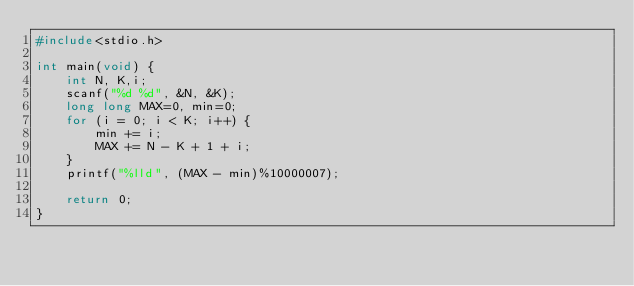<code> <loc_0><loc_0><loc_500><loc_500><_C_>#include<stdio.h>

int main(void) {
	int N, K,i;
	scanf("%d %d", &N, &K);
	long long MAX=0, min=0;
	for (i = 0; i < K; i++) {
		min += i;
		MAX += N - K + 1 + i;
	}
	printf("%lld", (MAX - min)%10000007);

	return 0;
}</code> 